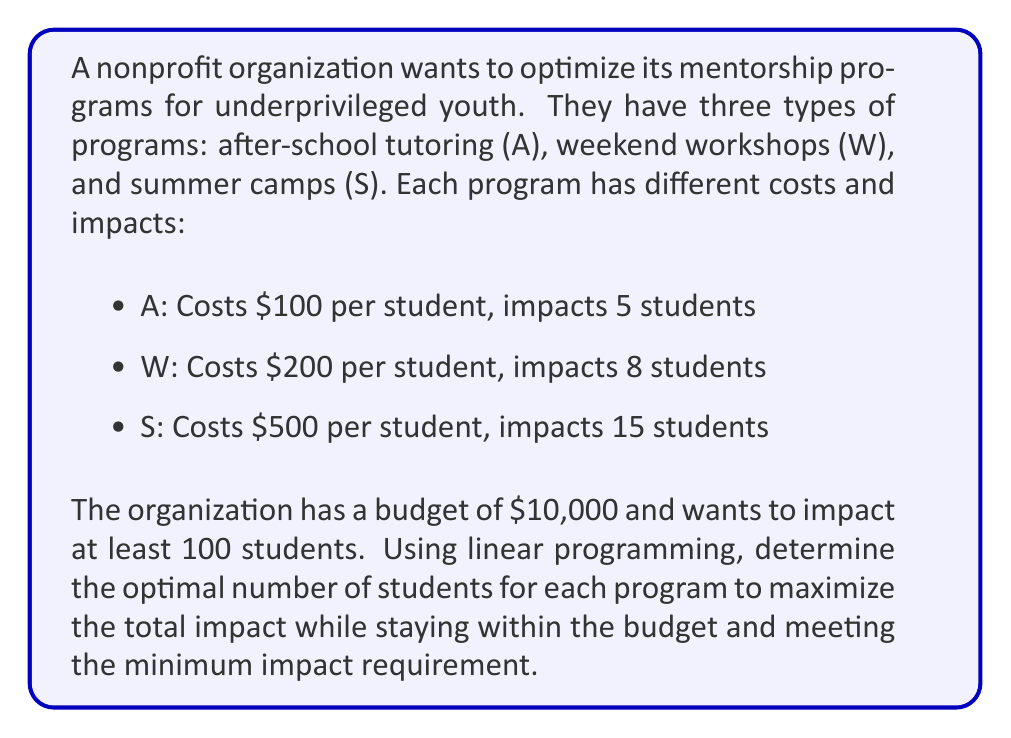Could you help me with this problem? Let's solve this step-by-step using linear programming:

1. Define variables:
   $x_A$ = number of students in after-school tutoring
   $x_W$ = number of students in weekend workshops
   $x_S$ = number of students in summer camps

2. Objective function (maximize impact):
   $$\text{Maximize } Z = 5x_A + 8x_W + 15x_S$$

3. Constraints:
   Budget constraint: $$100x_A + 200x_W + 500x_S \leq 10000$$
   Minimum impact constraint: $$5x_A + 8x_W + 15x_S \geq 100$$
   Non-negativity constraints: $$x_A, x_W, x_S \geq 0$$

4. Solve using the simplex method or linear programming software. The optimal solution is:
   $x_A = 0$, $x_W = 12.5$, $x_S = 0$

5. Since we can't have fractional students, we round down to the nearest integer:
   $x_A = 0$, $x_W = 12$, $x_S = 0$

6. Verify the solution:
   Cost: $200 \times 12 = 2400 \leq 10000$ (within budget)
   Impact: $8 \times 12 = 96$ (slightly below 100, but closest integer solution)

Therefore, the optimal solution is to have 12 students in weekend workshops, maximizing impact while staying within budget constraints.
Answer: 12 students in weekend workshops 